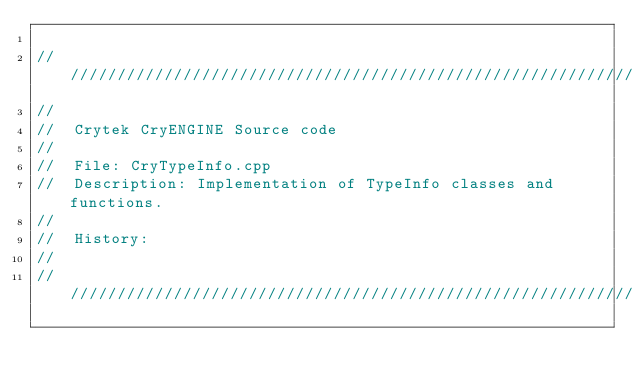Convert code to text. <code><loc_0><loc_0><loc_500><loc_500><_C++_>
//////////////////////////////////////////////////////////////////////
//
//	Crytek CryENGINE Source	code
//
//	File: CryTypeInfo.cpp
//	Description: Implementation	of TypeInfo classes and functions.
//
//	History:
//
//////////////////////////////////////////////////////////////////////
</code> 